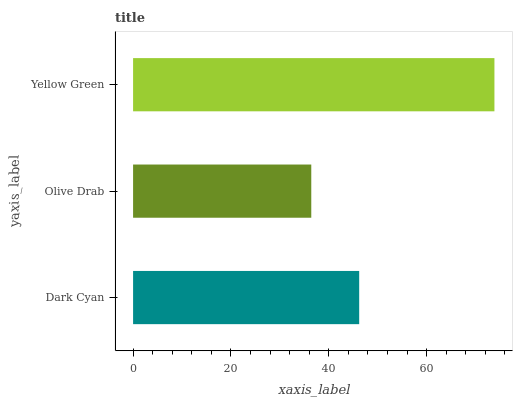Is Olive Drab the minimum?
Answer yes or no. Yes. Is Yellow Green the maximum?
Answer yes or no. Yes. Is Yellow Green the minimum?
Answer yes or no. No. Is Olive Drab the maximum?
Answer yes or no. No. Is Yellow Green greater than Olive Drab?
Answer yes or no. Yes. Is Olive Drab less than Yellow Green?
Answer yes or no. Yes. Is Olive Drab greater than Yellow Green?
Answer yes or no. No. Is Yellow Green less than Olive Drab?
Answer yes or no. No. Is Dark Cyan the high median?
Answer yes or no. Yes. Is Dark Cyan the low median?
Answer yes or no. Yes. Is Yellow Green the high median?
Answer yes or no. No. Is Yellow Green the low median?
Answer yes or no. No. 